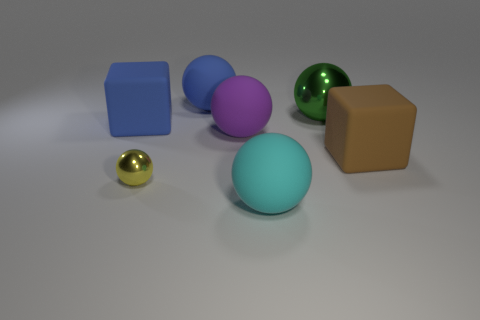Subtract all small yellow spheres. How many spheres are left? 4 Subtract all cyan balls. How many balls are left? 4 Subtract all brown spheres. Subtract all blue cubes. How many spheres are left? 5 Subtract all balls. How many objects are left? 2 Add 3 large red metallic cylinders. How many objects exist? 10 Add 4 purple objects. How many purple objects exist? 5 Subtract 0 cyan blocks. How many objects are left? 7 Subtract all big green objects. Subtract all big green metal objects. How many objects are left? 5 Add 7 large brown cubes. How many large brown cubes are left? 8 